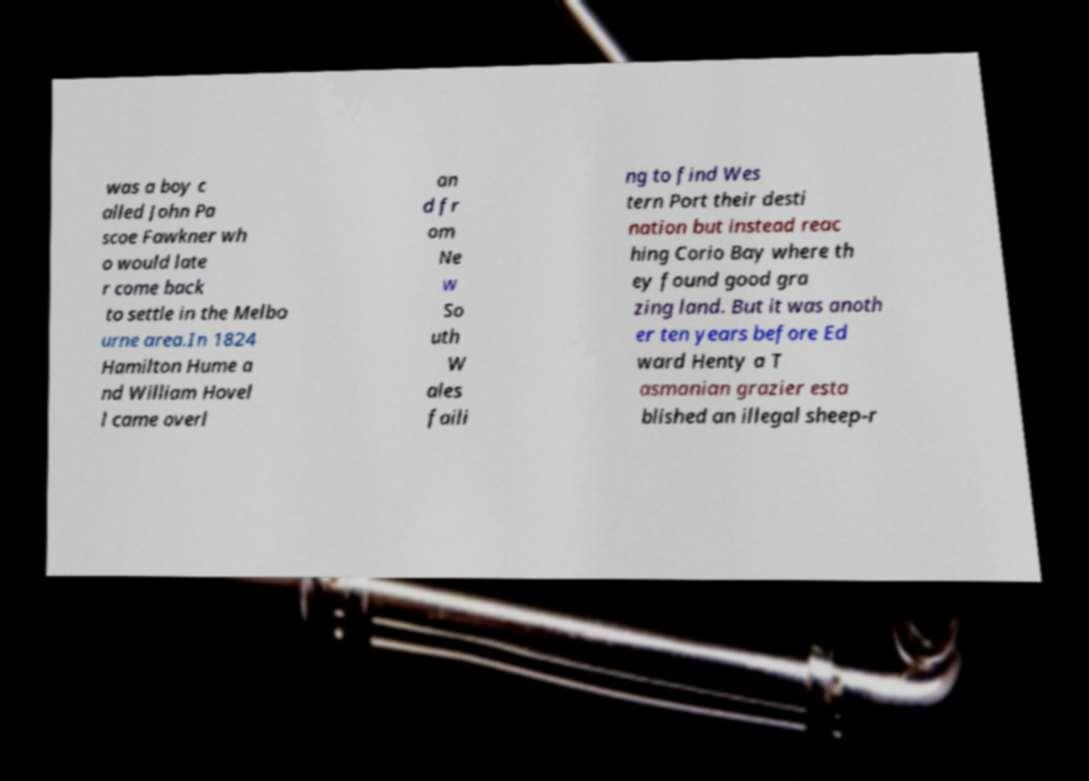Could you assist in decoding the text presented in this image and type it out clearly? was a boy c alled John Pa scoe Fawkner wh o would late r come back to settle in the Melbo urne area.In 1824 Hamilton Hume a nd William Hovel l came overl an d fr om Ne w So uth W ales faili ng to find Wes tern Port their desti nation but instead reac hing Corio Bay where th ey found good gra zing land. But it was anoth er ten years before Ed ward Henty a T asmanian grazier esta blished an illegal sheep-r 